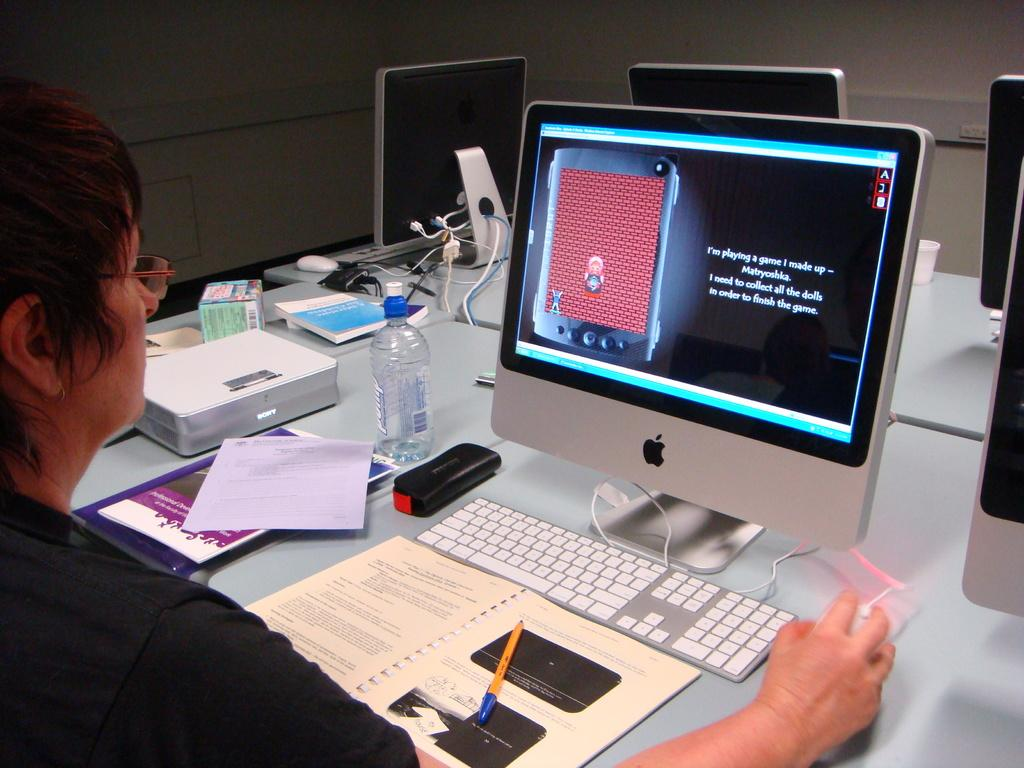<image>
Create a compact narrative representing the image presented. A person sits at an Apple Mac playing a game with Matryoshka dolls. 